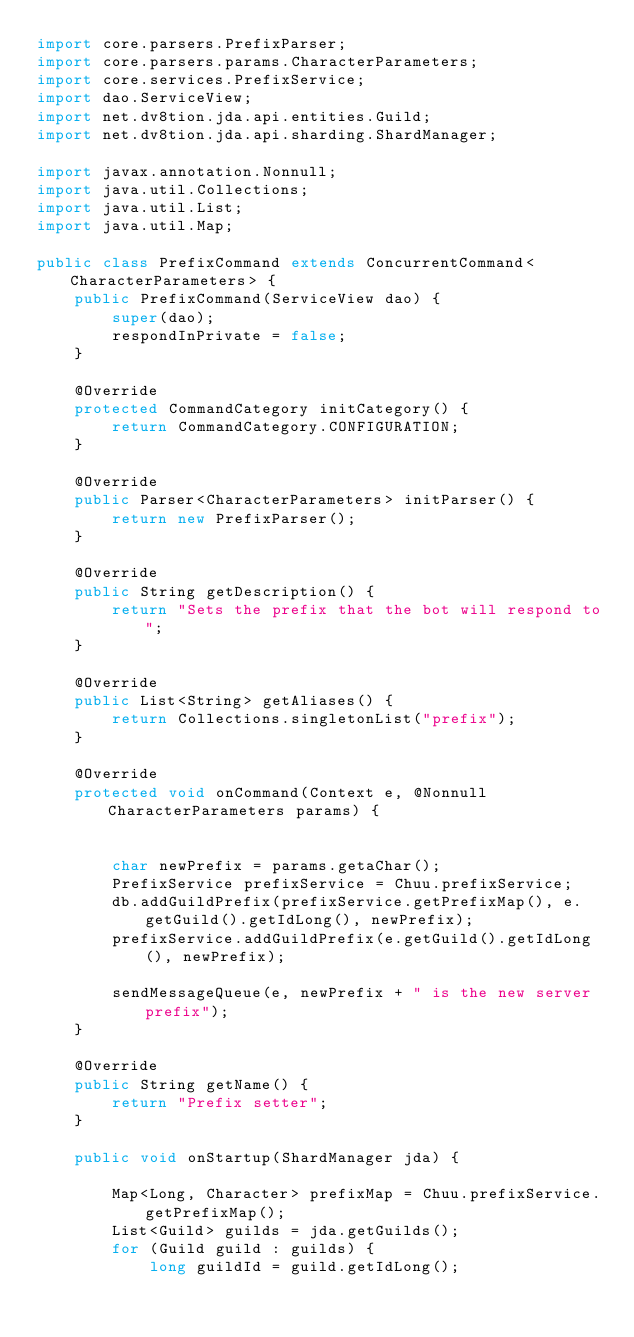Convert code to text. <code><loc_0><loc_0><loc_500><loc_500><_Java_>import core.parsers.PrefixParser;
import core.parsers.params.CharacterParameters;
import core.services.PrefixService;
import dao.ServiceView;
import net.dv8tion.jda.api.entities.Guild;
import net.dv8tion.jda.api.sharding.ShardManager;

import javax.annotation.Nonnull;
import java.util.Collections;
import java.util.List;
import java.util.Map;

public class PrefixCommand extends ConcurrentCommand<CharacterParameters> {
    public PrefixCommand(ServiceView dao) {
        super(dao);
        respondInPrivate = false;
    }

    @Override
    protected CommandCategory initCategory() {
        return CommandCategory.CONFIGURATION;
    }

    @Override
    public Parser<CharacterParameters> initParser() {
        return new PrefixParser();
    }

    @Override
    public String getDescription() {
        return "Sets the prefix that the bot will respond to";
    }

    @Override
    public List<String> getAliases() {
        return Collections.singletonList("prefix");
    }

    @Override
    protected void onCommand(Context e, @Nonnull CharacterParameters params) {


        char newPrefix = params.getaChar();
        PrefixService prefixService = Chuu.prefixService;
        db.addGuildPrefix(prefixService.getPrefixMap(), e.getGuild().getIdLong(), newPrefix);
        prefixService.addGuildPrefix(e.getGuild().getIdLong(), newPrefix);

        sendMessageQueue(e, newPrefix + " is the new server prefix");
    }

    @Override
    public String getName() {
        return "Prefix setter";
    }

    public void onStartup(ShardManager jda) {

        Map<Long, Character> prefixMap = Chuu.prefixService.getPrefixMap();
        List<Guild> guilds = jda.getGuilds();
        for (Guild guild : guilds) {
            long guildId = guild.getIdLong();</code> 